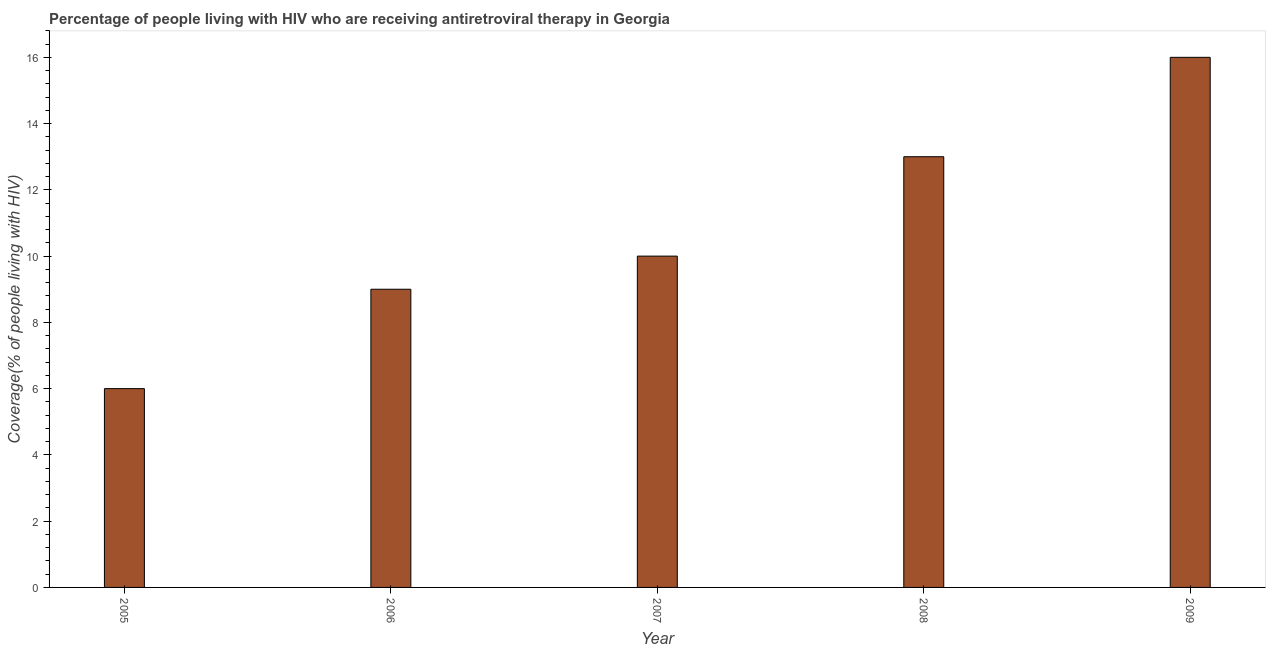What is the title of the graph?
Your answer should be very brief. Percentage of people living with HIV who are receiving antiretroviral therapy in Georgia. What is the label or title of the X-axis?
Keep it short and to the point. Year. What is the label or title of the Y-axis?
Provide a short and direct response. Coverage(% of people living with HIV). What is the antiretroviral therapy coverage in 2007?
Make the answer very short. 10. Across all years, what is the minimum antiretroviral therapy coverage?
Offer a terse response. 6. What is the sum of the antiretroviral therapy coverage?
Your answer should be compact. 54. What is the difference between the antiretroviral therapy coverage in 2007 and 2009?
Your response must be concise. -6. What is the average antiretroviral therapy coverage per year?
Make the answer very short. 10. What is the median antiretroviral therapy coverage?
Provide a succinct answer. 10. Do a majority of the years between 2008 and 2005 (inclusive) have antiretroviral therapy coverage greater than 7.2 %?
Provide a succinct answer. Yes. What is the ratio of the antiretroviral therapy coverage in 2005 to that in 2006?
Give a very brief answer. 0.67. Is the antiretroviral therapy coverage in 2005 less than that in 2009?
Provide a succinct answer. Yes. Is the difference between the antiretroviral therapy coverage in 2005 and 2009 greater than the difference between any two years?
Your response must be concise. Yes. Is the sum of the antiretroviral therapy coverage in 2005 and 2009 greater than the maximum antiretroviral therapy coverage across all years?
Ensure brevity in your answer.  Yes. What is the difference between the highest and the lowest antiretroviral therapy coverage?
Offer a very short reply. 10. How many bars are there?
Your answer should be very brief. 5. Are all the bars in the graph horizontal?
Ensure brevity in your answer.  No. How many years are there in the graph?
Ensure brevity in your answer.  5. What is the difference between two consecutive major ticks on the Y-axis?
Provide a succinct answer. 2. What is the Coverage(% of people living with HIV) of 2005?
Offer a very short reply. 6. What is the Coverage(% of people living with HIV) in 2007?
Keep it short and to the point. 10. What is the Coverage(% of people living with HIV) of 2009?
Your response must be concise. 16. What is the difference between the Coverage(% of people living with HIV) in 2005 and 2008?
Your response must be concise. -7. What is the difference between the Coverage(% of people living with HIV) in 2006 and 2009?
Make the answer very short. -7. What is the difference between the Coverage(% of people living with HIV) in 2007 and 2008?
Provide a short and direct response. -3. What is the difference between the Coverage(% of people living with HIV) in 2007 and 2009?
Provide a short and direct response. -6. What is the difference between the Coverage(% of people living with HIV) in 2008 and 2009?
Your answer should be compact. -3. What is the ratio of the Coverage(% of people living with HIV) in 2005 to that in 2006?
Your response must be concise. 0.67. What is the ratio of the Coverage(% of people living with HIV) in 2005 to that in 2007?
Your answer should be very brief. 0.6. What is the ratio of the Coverage(% of people living with HIV) in 2005 to that in 2008?
Ensure brevity in your answer.  0.46. What is the ratio of the Coverage(% of people living with HIV) in 2006 to that in 2007?
Make the answer very short. 0.9. What is the ratio of the Coverage(% of people living with HIV) in 2006 to that in 2008?
Make the answer very short. 0.69. What is the ratio of the Coverage(% of people living with HIV) in 2006 to that in 2009?
Offer a terse response. 0.56. What is the ratio of the Coverage(% of people living with HIV) in 2007 to that in 2008?
Ensure brevity in your answer.  0.77. What is the ratio of the Coverage(% of people living with HIV) in 2007 to that in 2009?
Give a very brief answer. 0.62. What is the ratio of the Coverage(% of people living with HIV) in 2008 to that in 2009?
Provide a short and direct response. 0.81. 